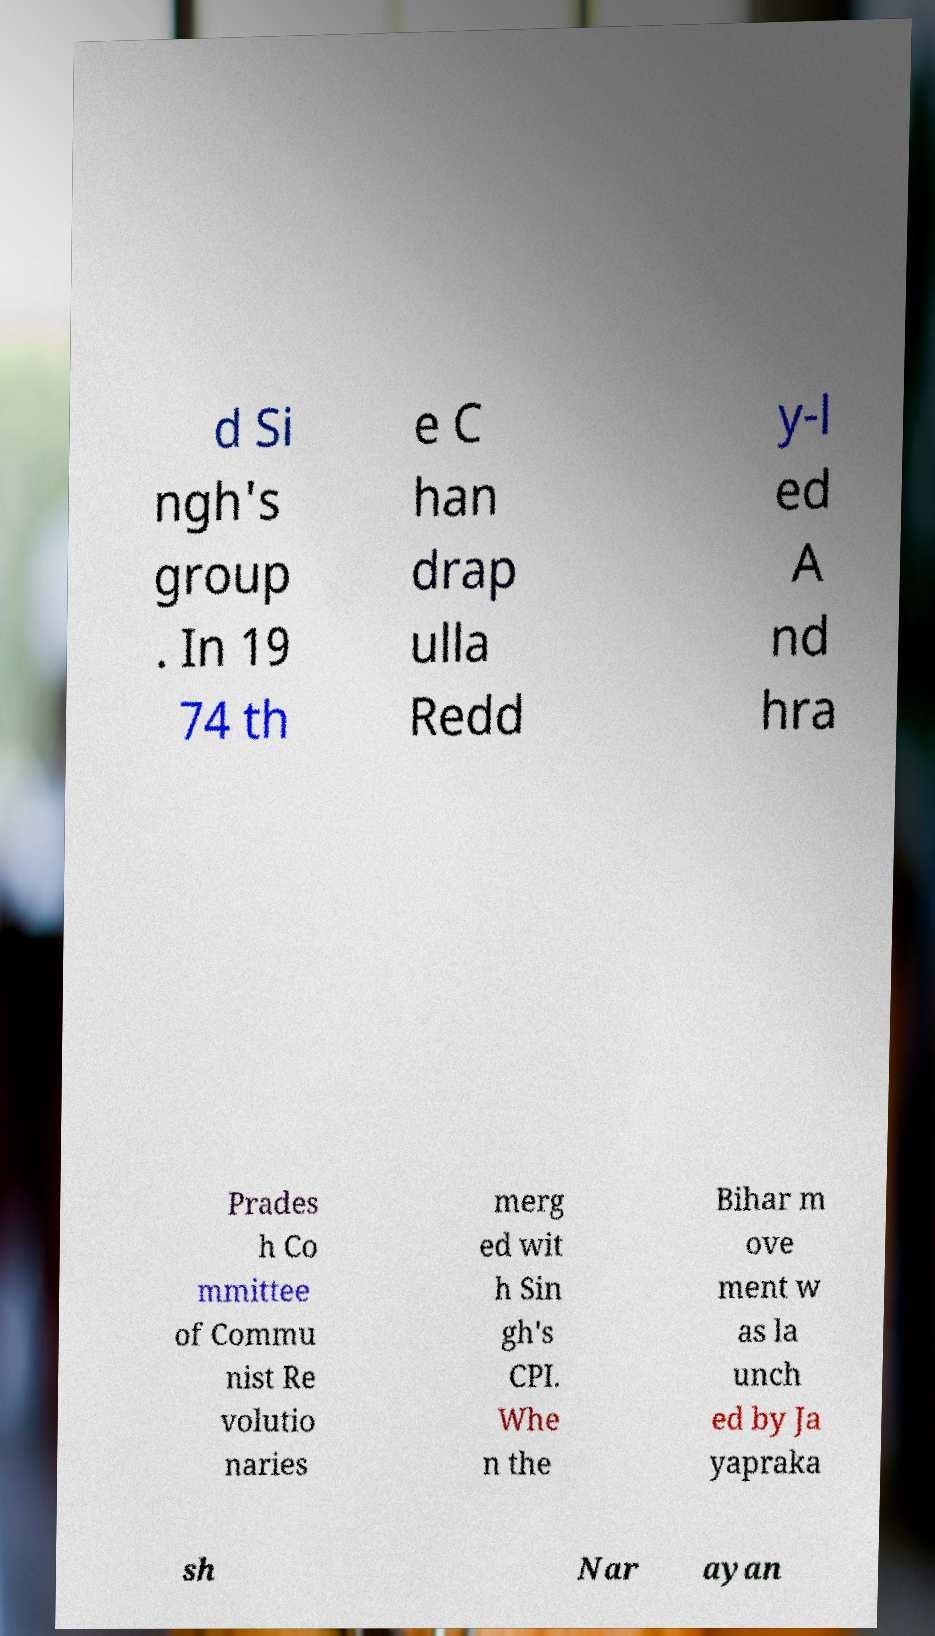Could you assist in decoding the text presented in this image and type it out clearly? d Si ngh's group . In 19 74 th e C han drap ulla Redd y-l ed A nd hra Prades h Co mmittee of Commu nist Re volutio naries merg ed wit h Sin gh's CPI. Whe n the Bihar m ove ment w as la unch ed by Ja yapraka sh Nar ayan 